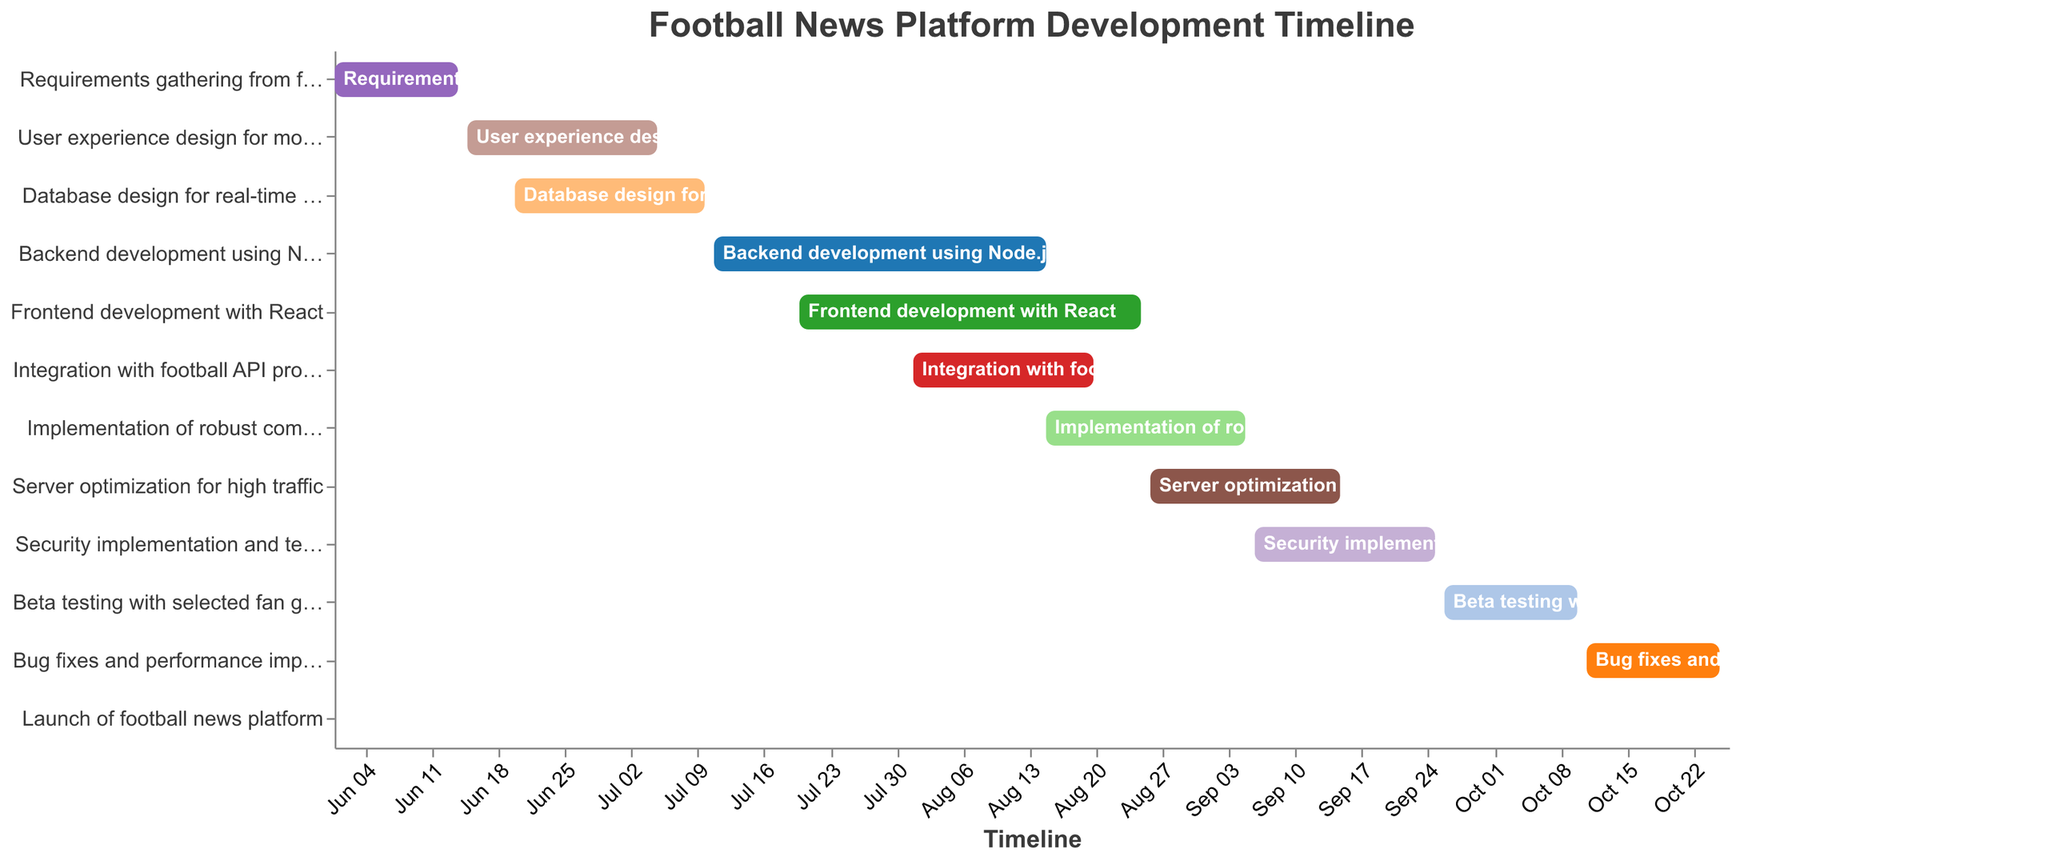What is the title of the Gantt Chart? The title is typically located at the top of the chart and summarizes the main subject.
Answer: Football News Platform Development Timeline Which phase comes immediately after 'Database design for real-time match updates'? By looking at the end date of 'Database design for real-time match updates', we see it ends on July 10, 2023. The task that starts the next day is 'Backend development using Node.js'.
Answer: Backend development using Node.js How many phases are there in total in this development timeline? By counting the number of tasks listed on the vertical axis, we can determine the total phases.
Answer: 12 Which phase has the longest duration, and what is this duration? We need to calculate the difference between the start and end dates for each task. 'Backend development using Node.js' starts on July 11 and ends on August 15, giving it the longest duration (36 days).
Answer: Backend development using Node.js, 36 days Is 'Frontend development with React' happening simultaneously with any other task? If so, which one(s)? By observing the start and end dates of 'Frontend development with React' (July 20 to August 25), we notice it overlaps with 'Backend development using Node.js' (July 11 to August 15) and 'Integration with football API providers' (August 1 to August 20).
Answer: Backend development using Node.js and Integration with football API providers What tasks are planned for August 2023? The tasks that include August in their time frames are examined: 'Backend development using Node.js' (until August 15), 'Frontend development with React' (July 20 to August 25), 'Integration with football API providers' (August 1 to August 20), and 'Implementation of robust comment system' (starts August 15).
Answer: Backend development using Node.js, Frontend development with React, Integration with football API providers, Implementation of robust comment system Which tasks overlap with the 'Security implementation and testing'? 'Security implementation and testing' runs from September 6 to September 25. Any tasks that overlap in this range are 'Implementation of robust comment system' (ends on September 5), 'Server optimization for high traffic' (ends on September 15), and 'Beta testing with selected fan groups' (starts on September 26). Only 'Server optimization for high traffic' overlaps.
Answer: Server optimization for high traffic What is the task duration for 'Bug fixes and performance improvements'? This task starts on October 11 and ends on October 25. Therefore, the duration is 15 days.
Answer: 15 days When does the 'Launch of football news platform' occur in the timeline, and which phases precede it? The launch is set for October 26. The preceding phases are 'Bug fixes and performance improvements' (ends October 25) and 'Beta testing with selected fan groups' (ends October 10).
Answer: October 26, follows Bug fixes and performance improvements and Beta testing with selected fan groups 